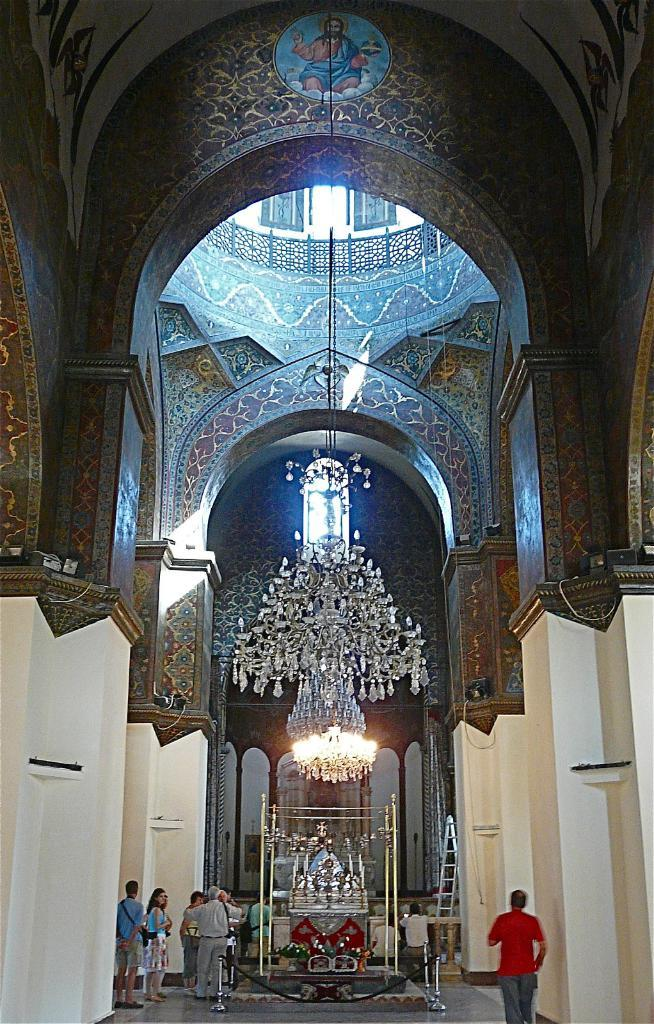Where is the setting of the image? The image is inside a building. What type of lighting fixture is present in the image? There is a chandelier in the image. Can you describe the people in the image? There are people in the image. What object might be used for reaching high places in the image? There is a ladder in the image. What type of patch can be seen on the people's clothes in the image? There is no patch visible on the people's clothes in the image. What is the people using to clean the chandelier in the image? There is no indication in the image that the people are cleaning the chandelier, nor is there any mention of a sponge or any cleaning tool. 